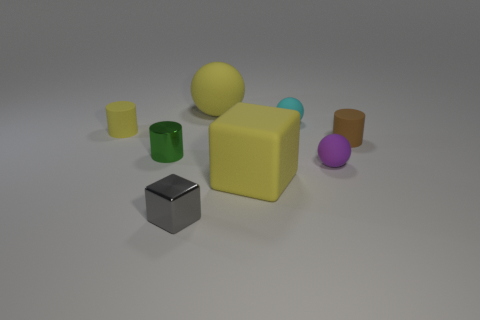There is a tiny cylinder that is made of the same material as the small yellow object; what color is it?
Offer a very short reply. Brown. Is the large yellow object right of the big ball made of the same material as the tiny sphere that is behind the small brown matte cylinder?
Ensure brevity in your answer.  Yes. The rubber cylinder that is the same color as the matte cube is what size?
Ensure brevity in your answer.  Small. What is the material of the thing on the left side of the tiny green cylinder?
Provide a succinct answer. Rubber. There is a thing that is on the right side of the purple rubber thing; is its shape the same as the tiny object that is behind the small yellow thing?
Offer a very short reply. No. What is the material of the cylinder that is the same color as the large rubber block?
Offer a terse response. Rubber. Are there any big yellow cubes?
Provide a succinct answer. Yes. There is a tiny yellow object that is the same shape as the green object; what is its material?
Your answer should be very brief. Rubber. Are there any blocks behind the yellow matte sphere?
Ensure brevity in your answer.  No. Do the large thing behind the tiny yellow matte thing and the small purple thing have the same material?
Offer a terse response. Yes. 